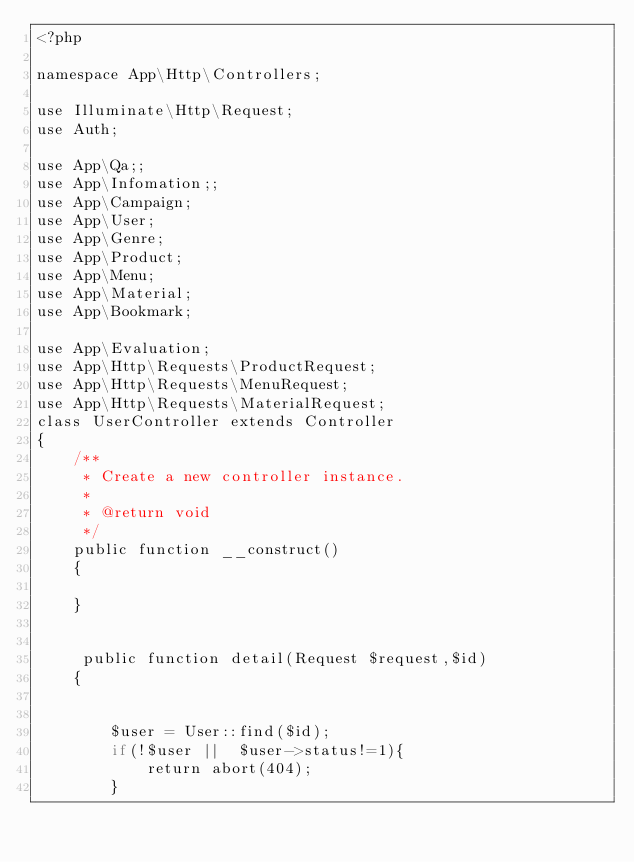<code> <loc_0><loc_0><loc_500><loc_500><_PHP_><?php

namespace App\Http\Controllers;

use Illuminate\Http\Request;
use Auth;

use App\Qa;;
use App\Infomation;;
use App\Campaign;
use App\User;
use App\Genre;
use App\Product;
use App\Menu;
use App\Material;
use App\Bookmark;

use App\Evaluation;
use App\Http\Requests\ProductRequest;
use App\Http\Requests\MenuRequest;
use App\Http\Requests\MaterialRequest;
class UserController extends Controller
{
    /**
     * Create a new controller instance.
     *
     * @return void
     */
    public function __construct()
    {

    }
     

     public function detail(Request $request,$id)
    {


        $user = User::find($id);
        if(!$user ||  $user->status!=1){
            return abort(404);
        }</code> 